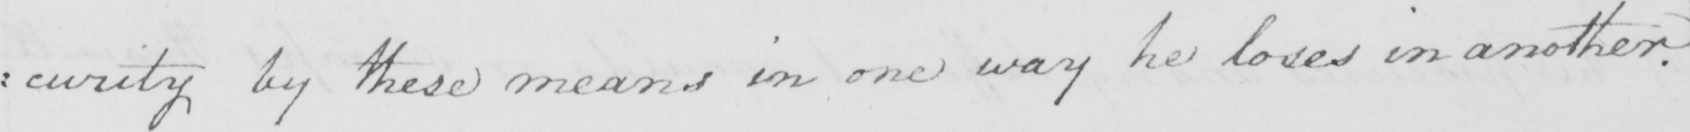Can you tell me what this handwritten text says? : curity by these means in one way he loses in another . 